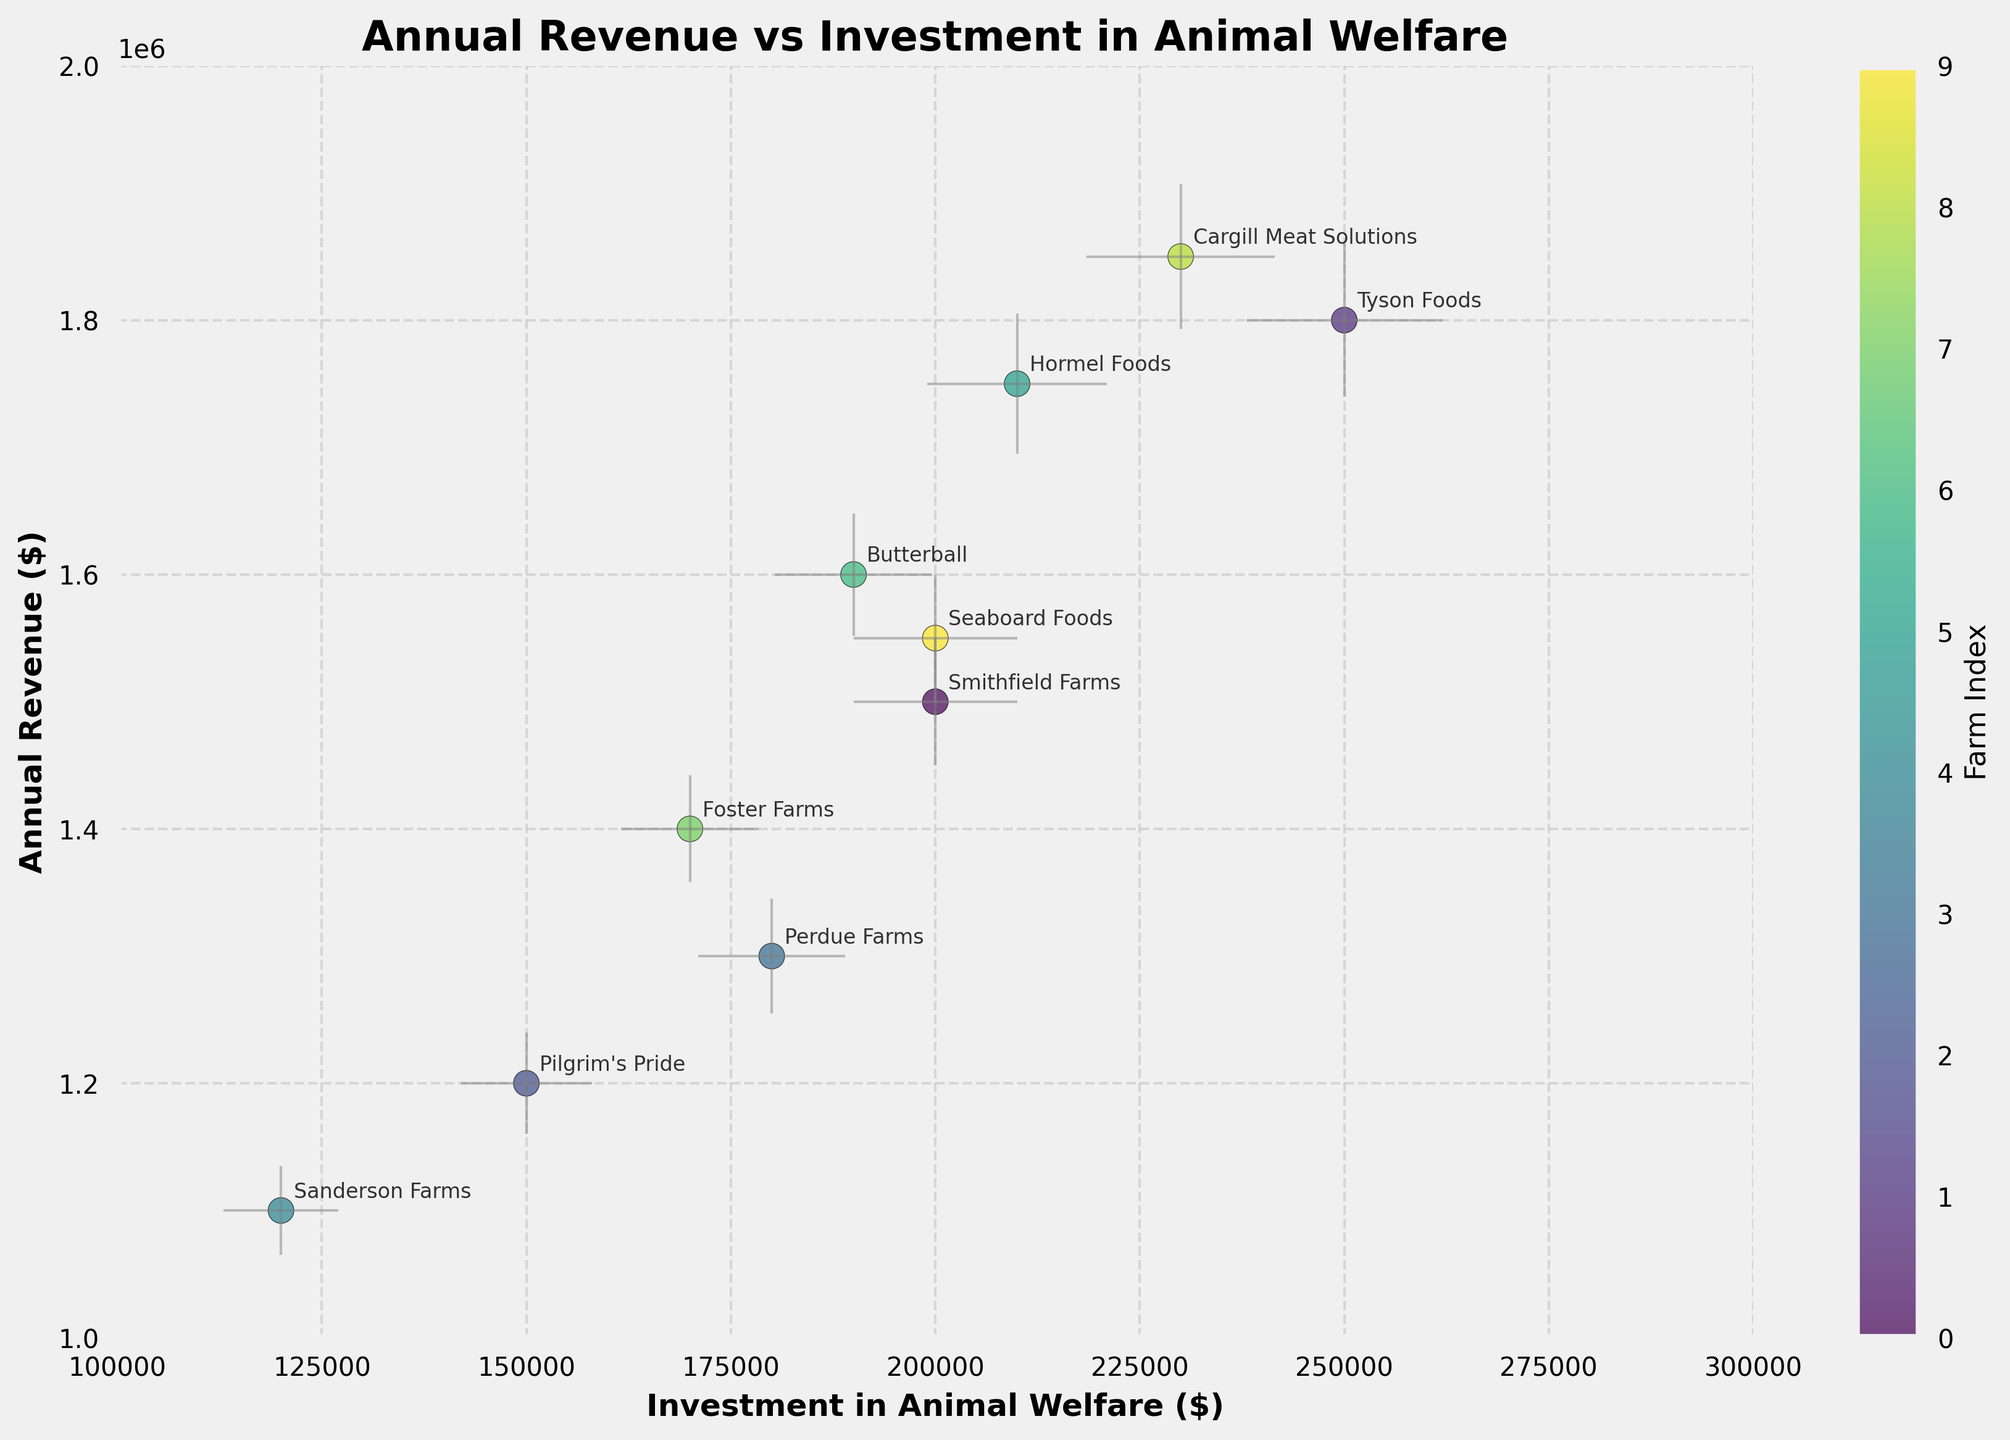Which farming unit has the highest annual revenue? The scatter plot shows the y-axis as annual revenue. The highest point along the y-axis corresponds to Cargill Meat Solutions.
Answer: Cargill Meat Solutions What is the range of investment in animal welfare? The scatter plot’s x-axis denotes investment in animal welfare. The lowest value is around 120,000, and the highest value is around 250,000.
Answer: 120,000 to 250,000 How many farming units have an annual revenue of at least $1,600,000? By observing the data points above the $1,600,000 mark on the y-axis, there are four farming units: Tyson Foods, Hormel Foods, Cargill Meat Solutions, and Seaboard Foods.
Answer: Four Which farming unit has the largest error margin in annual revenue? The error bars on the scatter plot indicate the error margin. The data point with the largest error bar in annual revenue corresponds to Tyson Foods.
Answer: Tyson Foods Is there a positive correlation between annual revenue and investment in animal welfare? By observing the general trend in the scatter plot, the data points tend to rise along the y-axis as they spread out more along the x-axis, indicating a positive relationship.
Answer: Yes What is the average investment in animal welfare for the farming units with annual revenues above $1,500,000? The farming units with revenues above $1,500,000 are Smithfield Farms, Tyson Foods, Hormel Foods, Butterball, Cargill Meat Solutions, and Seaboard Foods. Their investments are 200,000, 250,000, 210,000, 190,000, 230,000, and 200,000 respectively. The average is (200,000 + 250,000 + 210,000 + 190,000 + 230,000 + 200,000)/6 = 213,333.33.
Answer: 213,333.33 Which farming unit has a lower annual revenue between Pilgrim's Pride and Perdue Farms and by how much? By comparing their vertical positions, Pilgrim's Pride has an annual revenue of $1,200,000 and Perdue Farms has $1,300,000. The difference is $1,300,000 - $1,200,000 = $100,000.
Answer: Pilgrim's Pride, by $100,000 Do any farming units have overlapping error bars in investment in animal welfare? By checking the horizontal error bars, overlapping occurs between Seaboard Foods and Smithfield Farms.
Answer: Yes 